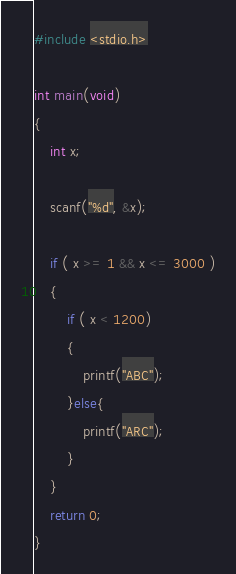<code> <loc_0><loc_0><loc_500><loc_500><_C_>#include <stdio.h>

int main(void)
{
	int x;
	
	scanf("%d", &x);
	
	if ( x >= 1 && x <= 3000 )
	{
		if ( x < 1200)
		{
			printf("ABC");
		}else{
			printf("ARC");
		}
	}
	return 0;
}
</code> 